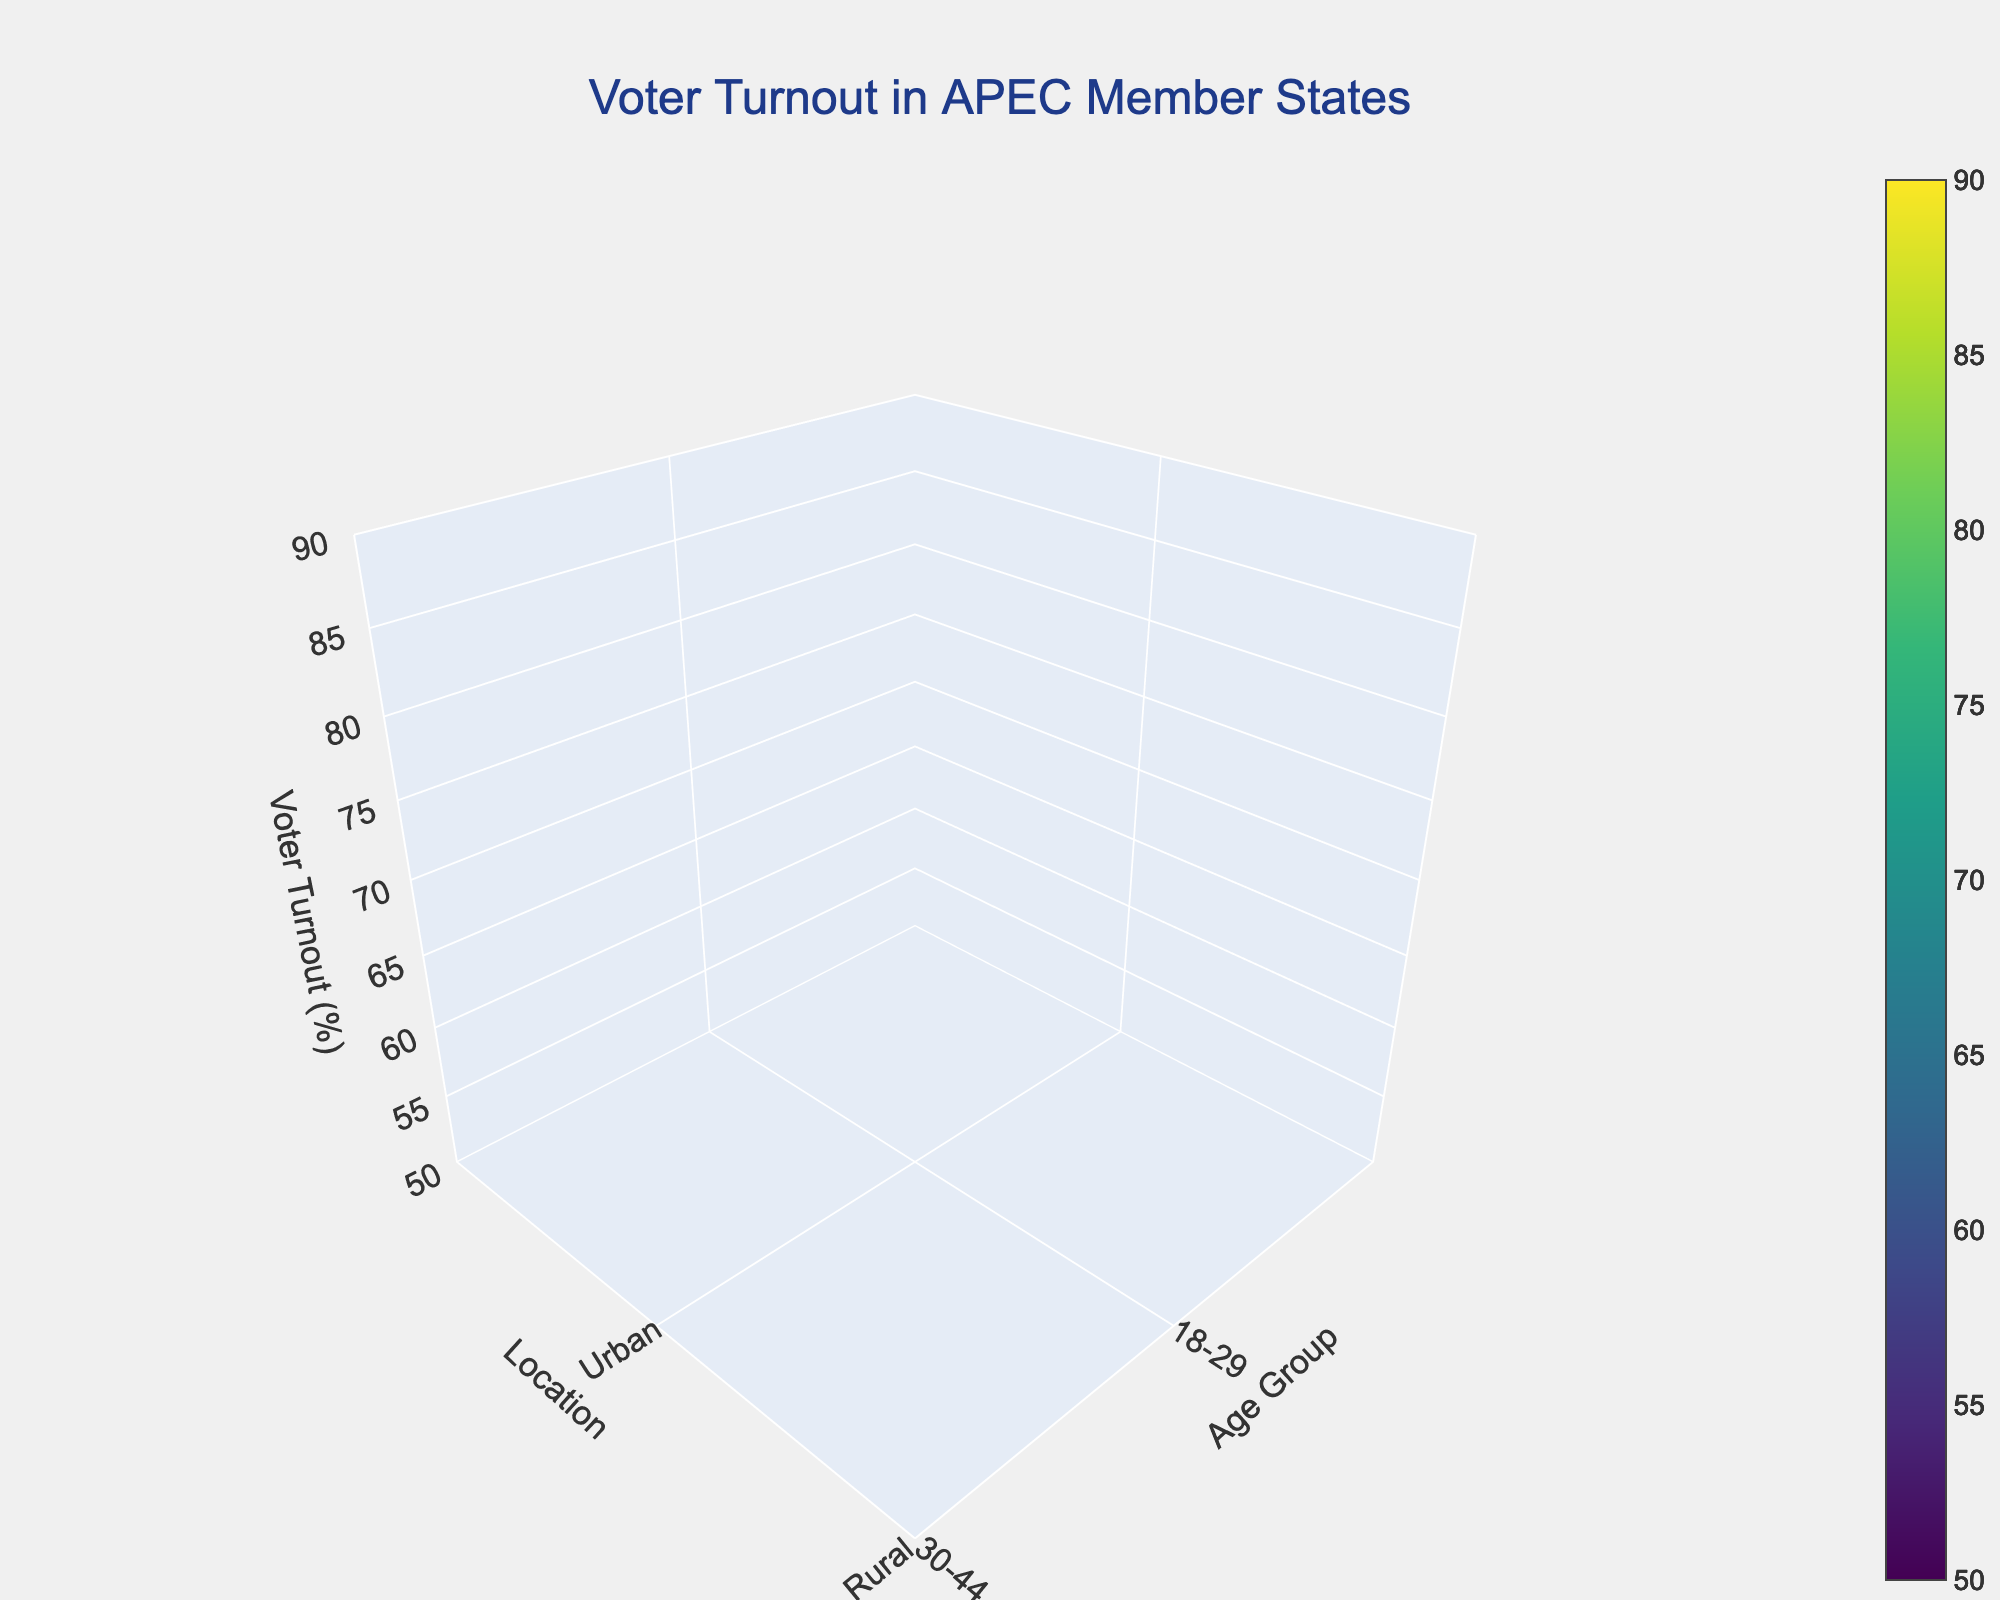What is the title of the figure? The title of the figure is usually displayed prominently at the top. In this case, it reads "Voter Turnout in APEC Member States".
Answer: Voter Turnout in APEC Member States What are the labels for the axes in the plot? By observing the plot, we can see the axis labels. The x-axis label is "Age Group", the y-axis label is "Location", and the z-axis label is "Voter Turnout (%)".
Answer: Age Group, Location, Voter Turnout (%) Which age group has the highest voter turnout in urban areas for South Korea? By examining the data for South Korea and looking at urban turnout, we identify the highest value under the age categories. The highest value is 84.6 for the 60+ age group.
Answer: 60+ How does voter turnout in rural areas of Australia compare between the 18-29 and 60+ age groups? From the plot, identify the voter turnout for these age groups in rural Australia, which are 68.3 for 18-29 and 86.5 for 60+. Compare the two values.
Answer: 60+ is higher Which country has the lowest voter turnout in the 18-29 age group in rural areas? Check the voter turnout values for the 18-29 age group in rural areas across all countries mentioned. The lowest value is 54.7 for Japan.
Answer: Japan How does the average voter turnout in urban areas across all age groups for Japan compare to that of South Korea? First, calculate the average voter turnout for urban areas across all age groups in Japan and South Korea. Japan: (58.2+67.5+76.3+81.9)/4 = 70.975, South Korea: (65.3+72.1+79.8+84.6)/4 = 75.45. Compare the two averages.
Answer: South Korea is higher Which country shows a consistent increase in voter turnout with age in rural areas? Review the voter turnout values for rural areas in each country. Identify which country has an increasing trend in turnout as age increases. All countries show an increase, but the most consistent is Australia.
Answer: Australia 